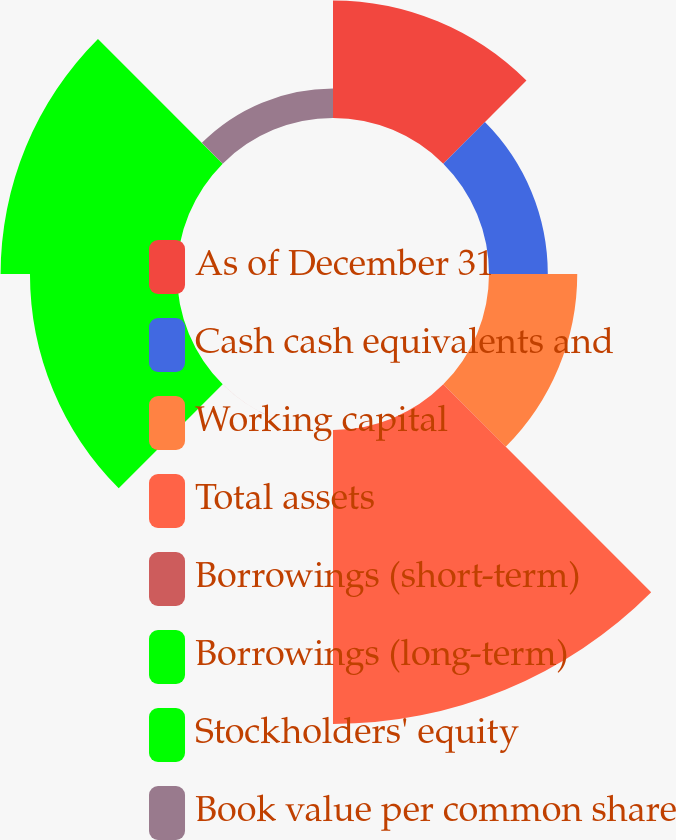<chart> <loc_0><loc_0><loc_500><loc_500><pie_chart><fcel>As of December 31<fcel>Cash cash equivalents and<fcel>Working capital<fcel>Total assets<fcel>Borrowings (short-term)<fcel>Borrowings (long-term)<fcel>Stockholders' equity<fcel>Book value per common share<nl><fcel>12.9%<fcel>6.45%<fcel>9.68%<fcel>32.25%<fcel>0.01%<fcel>16.13%<fcel>19.35%<fcel>3.23%<nl></chart> 